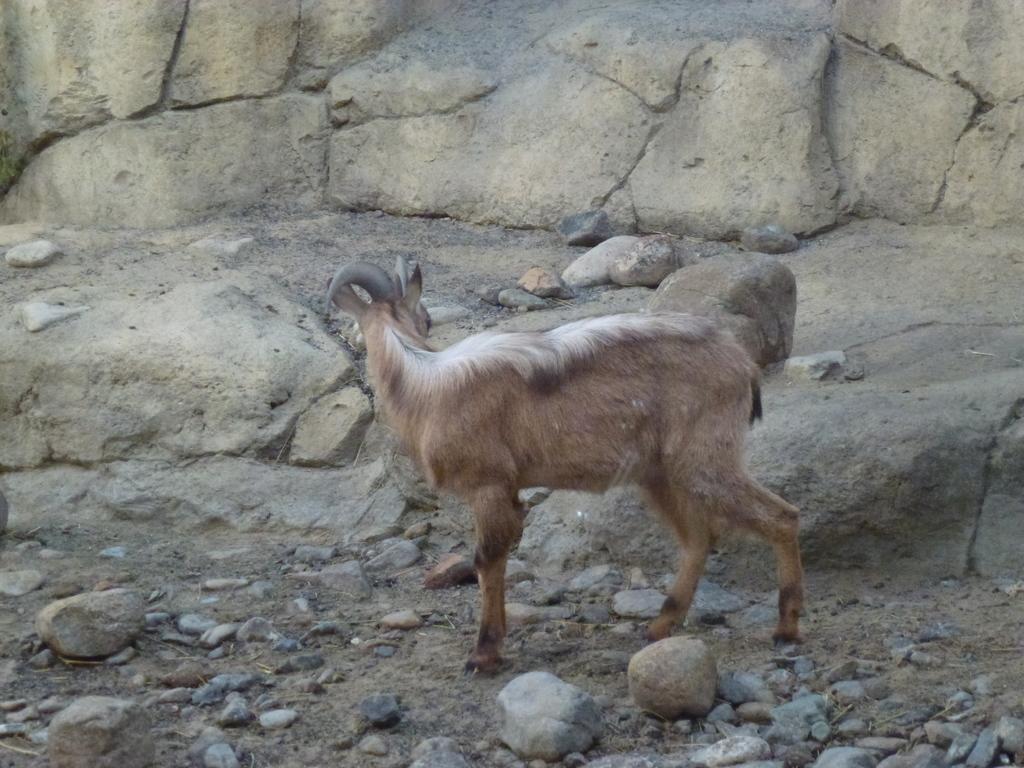Could you give a brief overview of what you see in this image? In this image we can see an animal, there are some stones and rocks. 